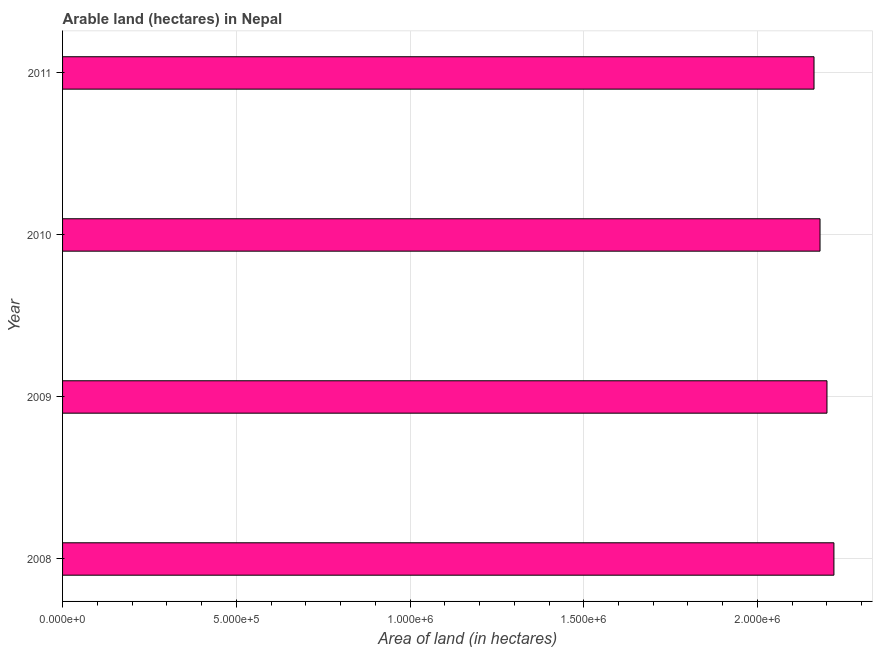Does the graph contain any zero values?
Your response must be concise. No. What is the title of the graph?
Give a very brief answer. Arable land (hectares) in Nepal. What is the label or title of the X-axis?
Your answer should be very brief. Area of land (in hectares). What is the label or title of the Y-axis?
Provide a succinct answer. Year. What is the area of land in 2010?
Make the answer very short. 2.18e+06. Across all years, what is the maximum area of land?
Your answer should be compact. 2.22e+06. Across all years, what is the minimum area of land?
Your answer should be compact. 2.16e+06. In which year was the area of land maximum?
Provide a short and direct response. 2008. In which year was the area of land minimum?
Provide a succinct answer. 2011. What is the sum of the area of land?
Keep it short and to the point. 8.76e+06. What is the difference between the area of land in 2008 and 2009?
Your answer should be very brief. 2.00e+04. What is the average area of land per year?
Your answer should be compact. 2.19e+06. What is the median area of land?
Ensure brevity in your answer.  2.19e+06. In how many years, is the area of land greater than 600000 hectares?
Offer a very short reply. 4. Do a majority of the years between 2008 and 2010 (inclusive) have area of land greater than 800000 hectares?
Offer a terse response. Yes. Is the difference between the area of land in 2010 and 2011 greater than the difference between any two years?
Provide a short and direct response. No. What is the difference between the highest and the second highest area of land?
Offer a terse response. 2.00e+04. Is the sum of the area of land in 2008 and 2010 greater than the maximum area of land across all years?
Your response must be concise. Yes. What is the difference between the highest and the lowest area of land?
Offer a very short reply. 5.73e+04. How many bars are there?
Provide a short and direct response. 4. Are all the bars in the graph horizontal?
Give a very brief answer. Yes. Are the values on the major ticks of X-axis written in scientific E-notation?
Your answer should be compact. Yes. What is the Area of land (in hectares) of 2008?
Keep it short and to the point. 2.22e+06. What is the Area of land (in hectares) of 2009?
Offer a very short reply. 2.20e+06. What is the Area of land (in hectares) of 2010?
Your response must be concise. 2.18e+06. What is the Area of land (in hectares) in 2011?
Keep it short and to the point. 2.16e+06. What is the difference between the Area of land (in hectares) in 2008 and 2009?
Give a very brief answer. 2.00e+04. What is the difference between the Area of land (in hectares) in 2008 and 2011?
Keep it short and to the point. 5.73e+04. What is the difference between the Area of land (in hectares) in 2009 and 2011?
Provide a short and direct response. 3.73e+04. What is the difference between the Area of land (in hectares) in 2010 and 2011?
Keep it short and to the point. 1.73e+04. What is the ratio of the Area of land (in hectares) in 2008 to that in 2009?
Give a very brief answer. 1.01. What is the ratio of the Area of land (in hectares) in 2008 to that in 2011?
Provide a succinct answer. 1.03. What is the ratio of the Area of land (in hectares) in 2009 to that in 2011?
Provide a short and direct response. 1.02. 